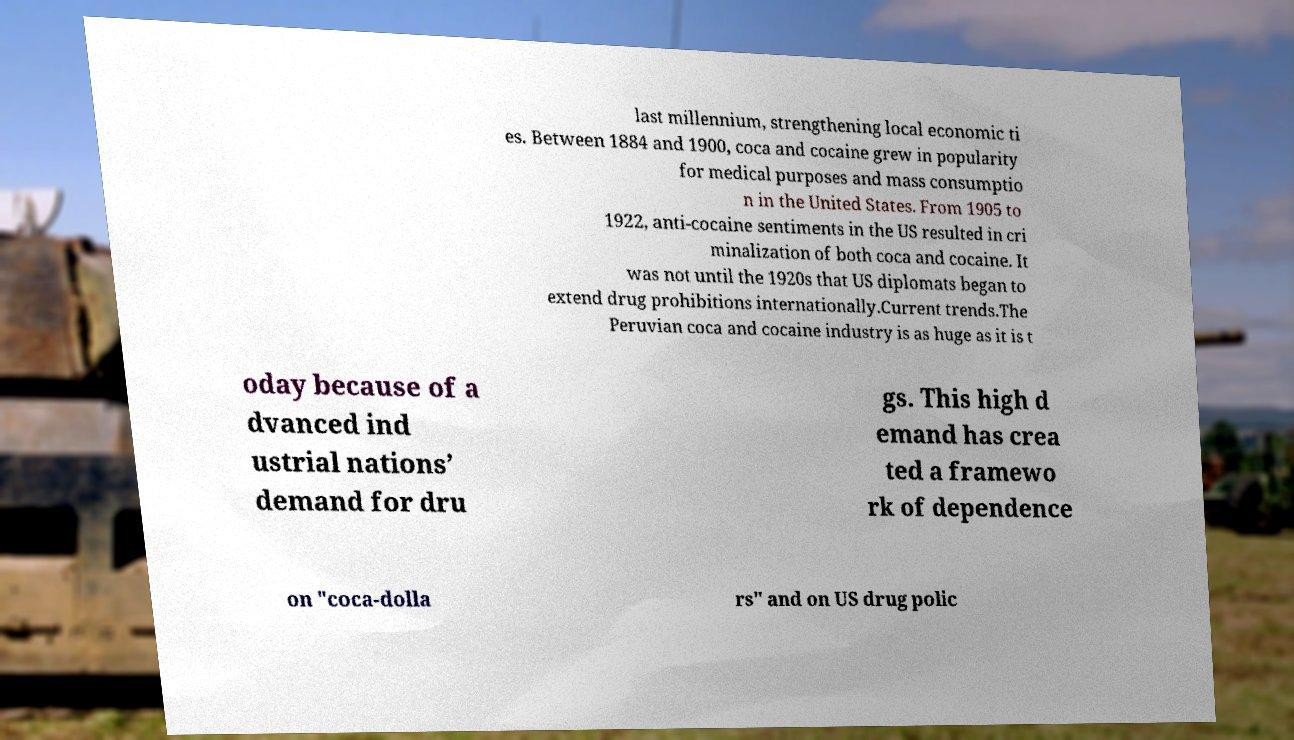Can you read and provide the text displayed in the image?This photo seems to have some interesting text. Can you extract and type it out for me? last millennium, strengthening local economic ti es. Between 1884 and 1900, coca and cocaine grew in popularity for medical purposes and mass consumptio n in the United States. From 1905 to 1922, anti-cocaine sentiments in the US resulted in cri minalization of both coca and cocaine. It was not until the 1920s that US diplomats began to extend drug prohibitions internationally.Current trends.The Peruvian coca and cocaine industry is as huge as it is t oday because of a dvanced ind ustrial nations’ demand for dru gs. This high d emand has crea ted a framewo rk of dependence on "coca-dolla rs" and on US drug polic 